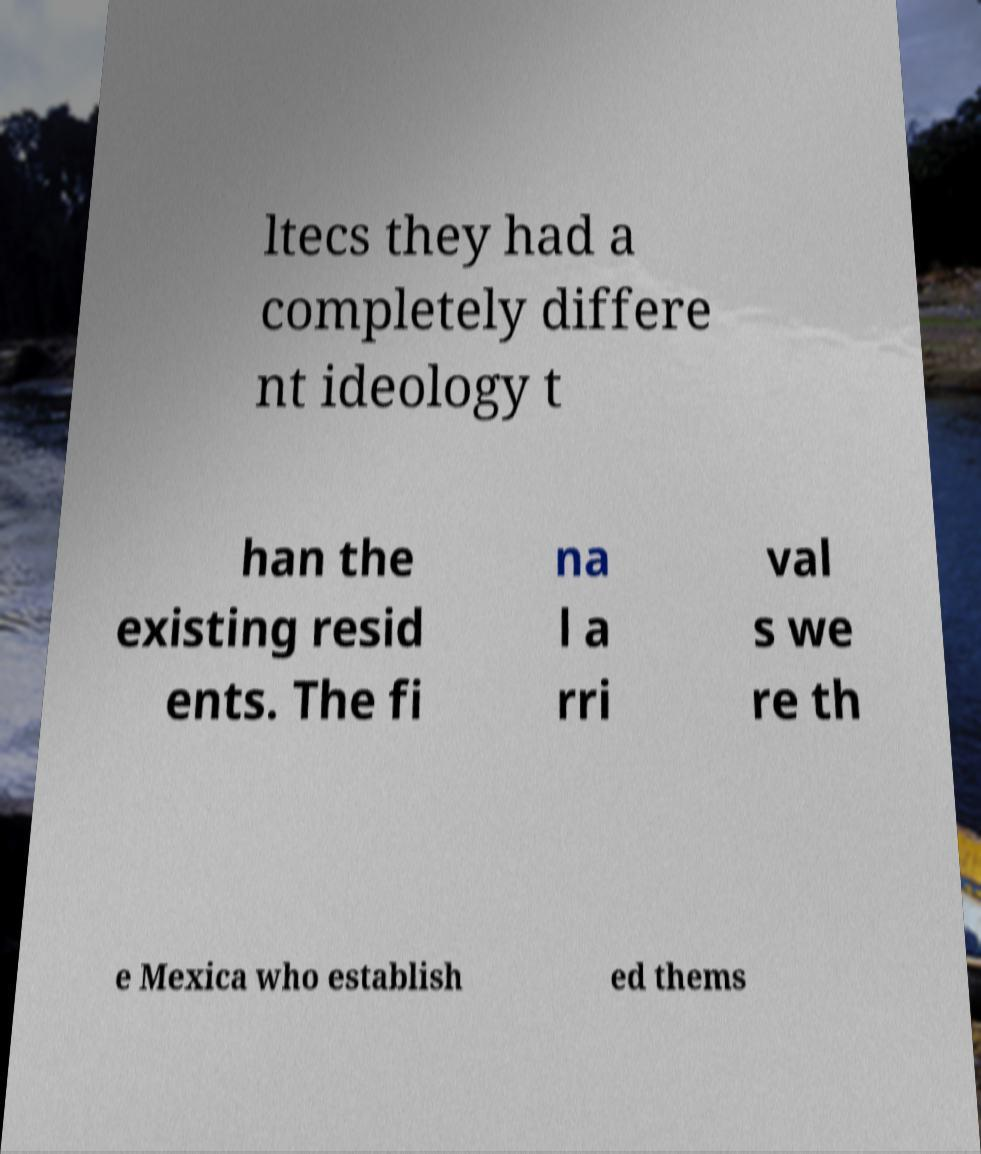Can you read and provide the text displayed in the image?This photo seems to have some interesting text. Can you extract and type it out for me? ltecs they had a completely differe nt ideology t han the existing resid ents. The fi na l a rri val s we re th e Mexica who establish ed thems 